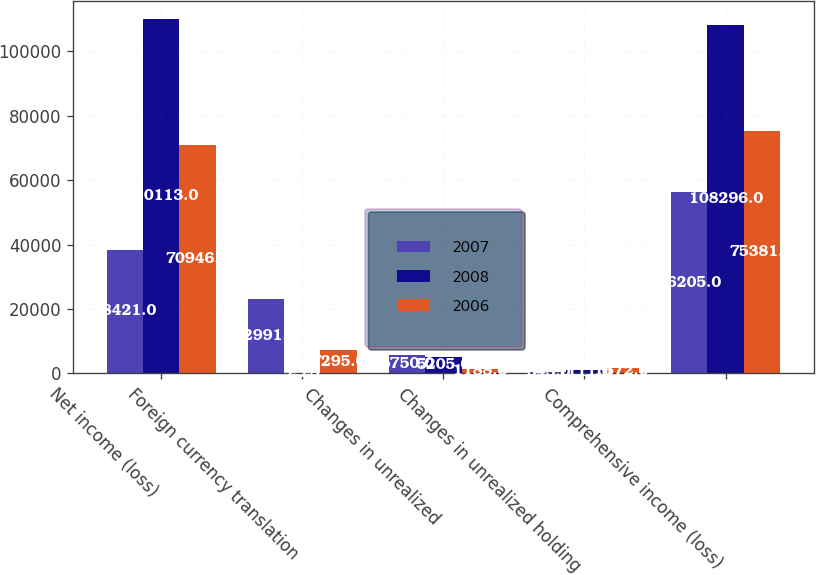Convert chart to OTSL. <chart><loc_0><loc_0><loc_500><loc_500><stacked_bar_chart><ecel><fcel>Net income (loss)<fcel>Foreign currency translation<fcel>Changes in unrealized<fcel>Changes in unrealized holding<fcel>Comprehensive income (loss)<nl><fcel>2007<fcel>38421<fcel>22991<fcel>5750<fcel>543<fcel>56205<nl><fcel>2008<fcel>110113<fcel>2.28<fcel>5205<fcel>1111<fcel>108296<nl><fcel>2006<fcel>70946<fcel>7295<fcel>1188<fcel>1672<fcel>75381<nl></chart> 